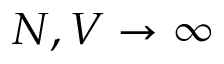Convert formula to latex. <formula><loc_0><loc_0><loc_500><loc_500>N , V \to \infty</formula> 